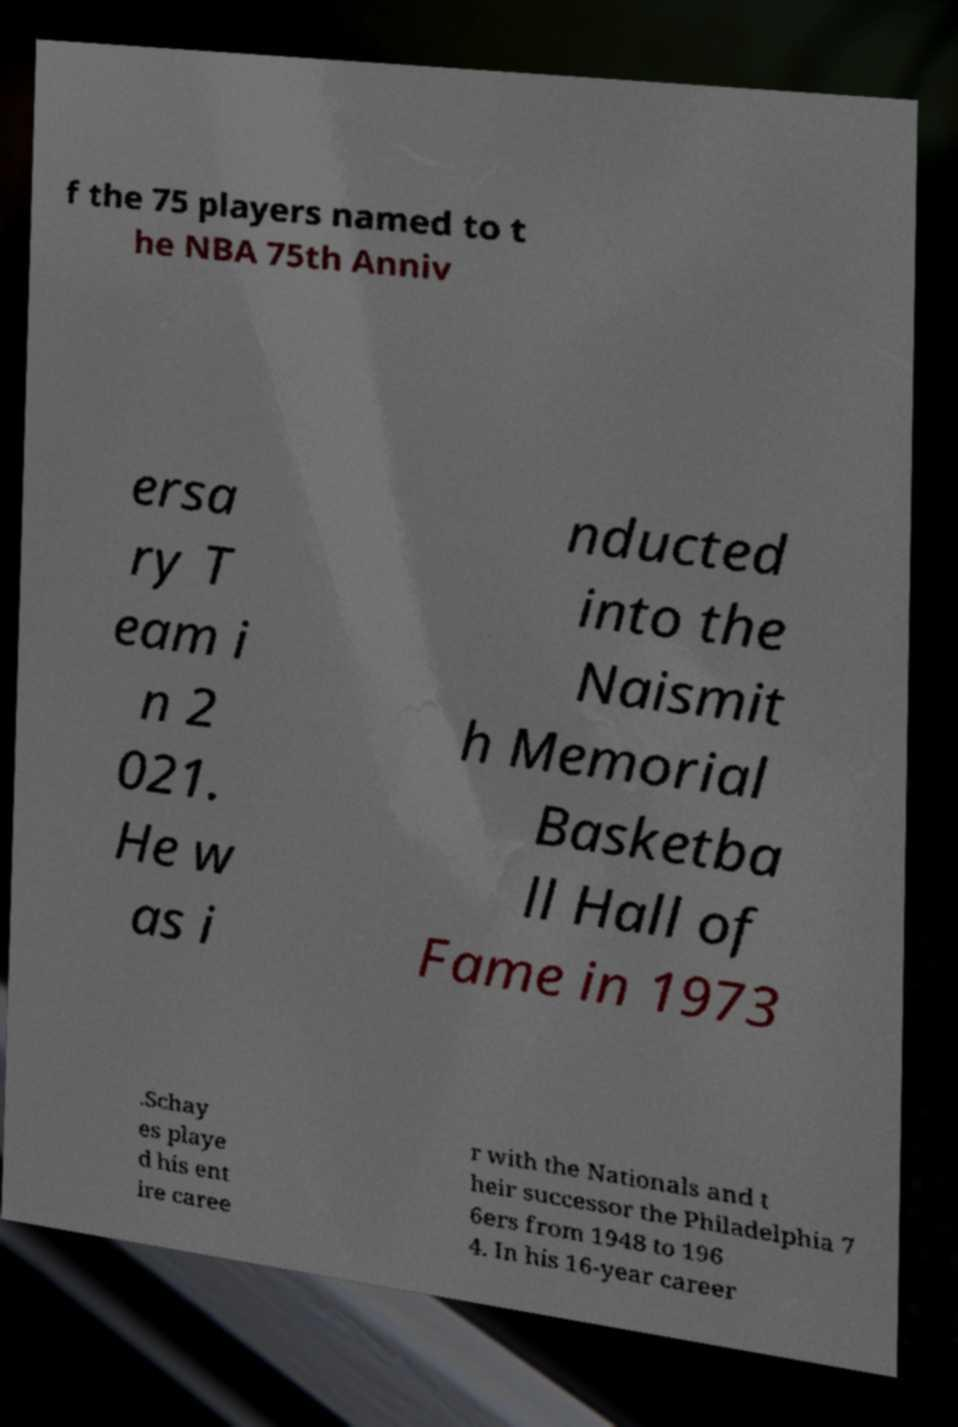What messages or text are displayed in this image? I need them in a readable, typed format. f the 75 players named to t he NBA 75th Anniv ersa ry T eam i n 2 021. He w as i nducted into the Naismit h Memorial Basketba ll Hall of Fame in 1973 .Schay es playe d his ent ire caree r with the Nationals and t heir successor the Philadelphia 7 6ers from 1948 to 196 4. In his 16-year career 